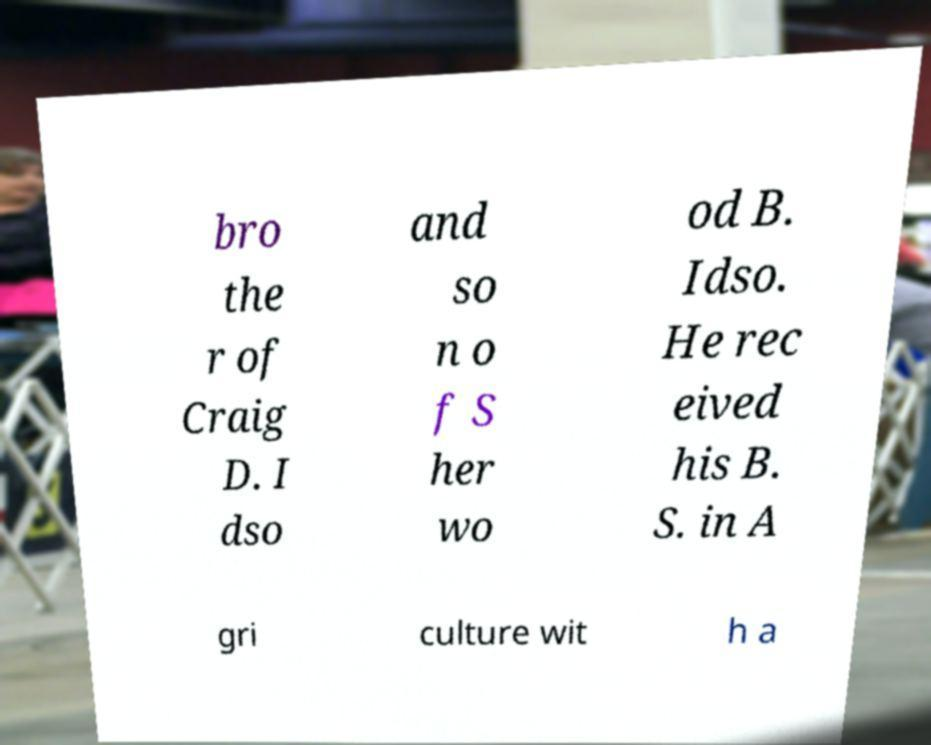Please read and relay the text visible in this image. What does it say? bro the r of Craig D. I dso and so n o f S her wo od B. Idso. He rec eived his B. S. in A gri culture wit h a 